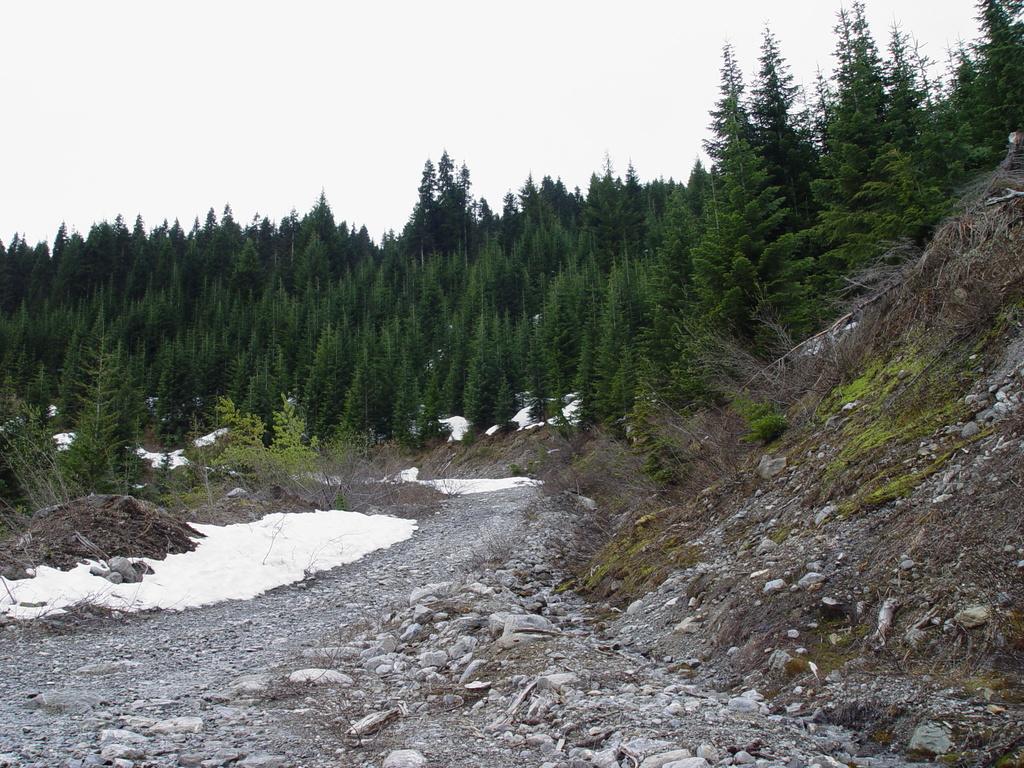Please provide a concise description of this image. There is a small hill and beside the hill there are many stones and in the left side some area is covered with a lot of snow and in the background there is a thicket. 